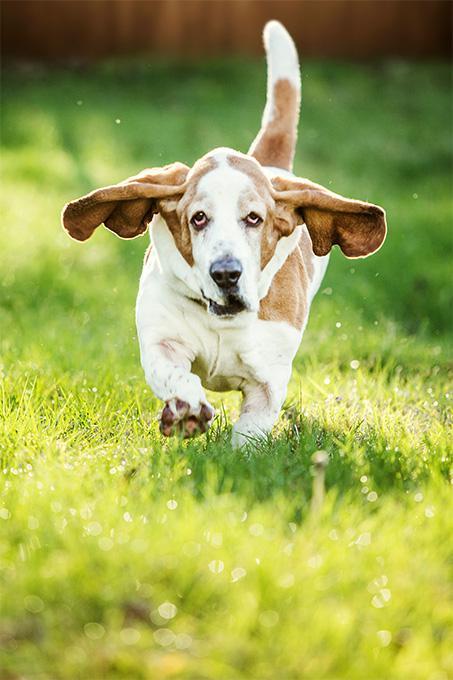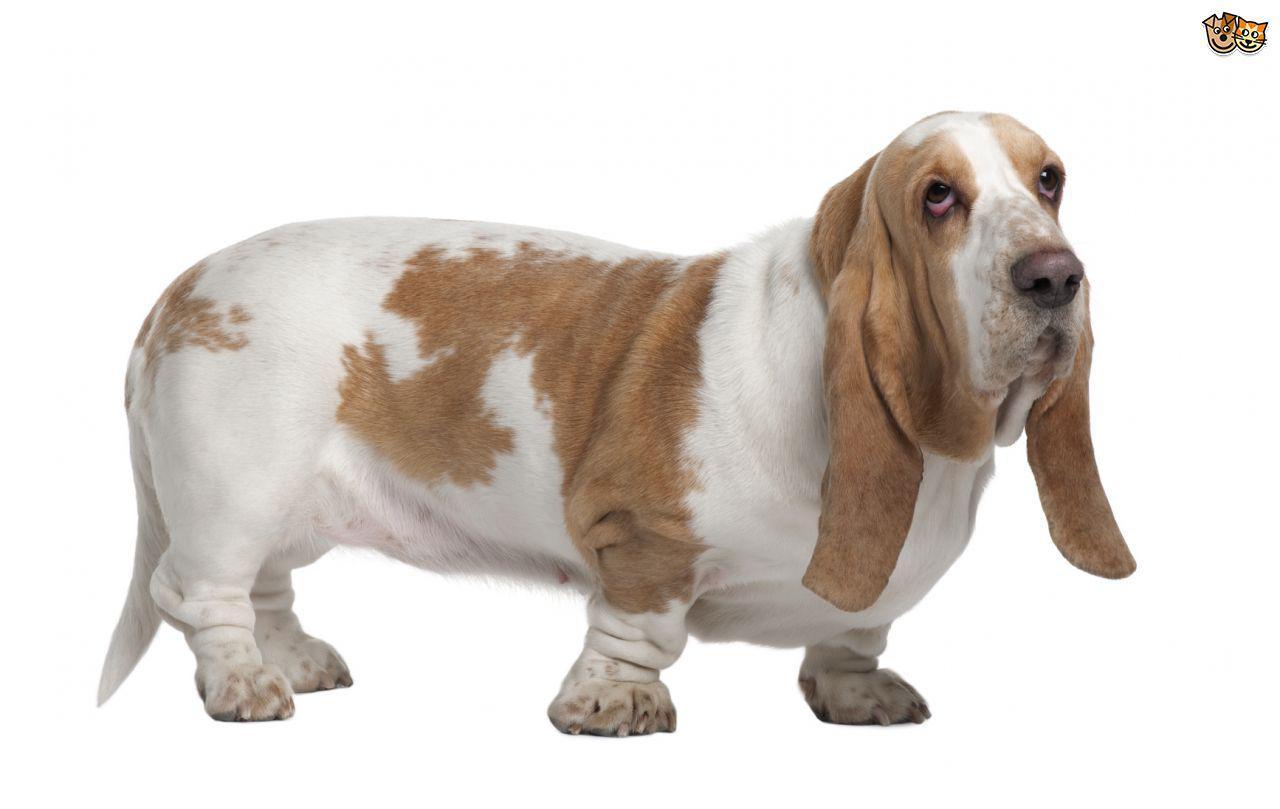The first image is the image on the left, the second image is the image on the right. Examine the images to the left and right. Is the description "At least one dog has no visible black in their fur." accurate? Answer yes or no. Yes. 